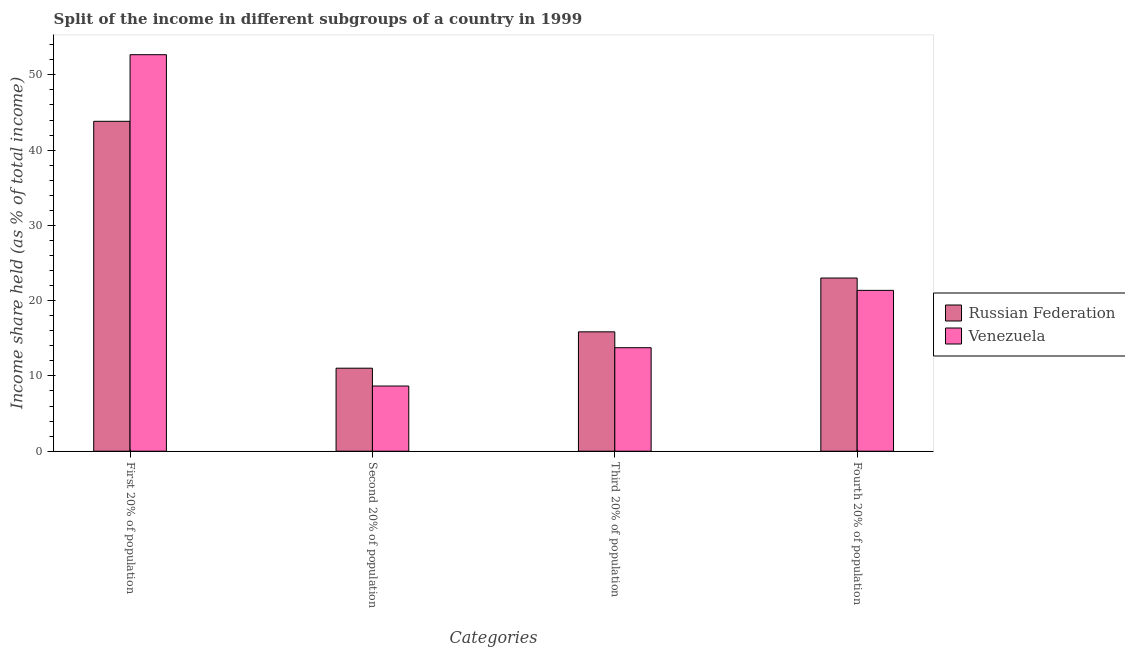How many different coloured bars are there?
Your response must be concise. 2. How many groups of bars are there?
Provide a succinct answer. 4. How many bars are there on the 1st tick from the left?
Your response must be concise. 2. How many bars are there on the 1st tick from the right?
Make the answer very short. 2. What is the label of the 4th group of bars from the left?
Provide a succinct answer. Fourth 20% of population. What is the share of the income held by third 20% of the population in Russian Federation?
Keep it short and to the point. 15.86. Across all countries, what is the maximum share of the income held by fourth 20% of the population?
Give a very brief answer. 23.01. Across all countries, what is the minimum share of the income held by third 20% of the population?
Offer a very short reply. 13.75. In which country was the share of the income held by first 20% of the population maximum?
Give a very brief answer. Venezuela. In which country was the share of the income held by second 20% of the population minimum?
Offer a terse response. Venezuela. What is the total share of the income held by third 20% of the population in the graph?
Offer a very short reply. 29.61. What is the difference between the share of the income held by second 20% of the population in Venezuela and that in Russian Federation?
Offer a terse response. -2.37. What is the difference between the share of the income held by second 20% of the population in Venezuela and the share of the income held by third 20% of the population in Russian Federation?
Your answer should be compact. -7.2. What is the average share of the income held by second 20% of the population per country?
Offer a very short reply. 9.84. What is the difference between the share of the income held by second 20% of the population and share of the income held by fourth 20% of the population in Russian Federation?
Your answer should be compact. -11.98. In how many countries, is the share of the income held by first 20% of the population greater than 34 %?
Give a very brief answer. 2. What is the ratio of the share of the income held by third 20% of the population in Venezuela to that in Russian Federation?
Offer a terse response. 0.87. Is the share of the income held by fourth 20% of the population in Russian Federation less than that in Venezuela?
Your response must be concise. No. Is the difference between the share of the income held by second 20% of the population in Russian Federation and Venezuela greater than the difference between the share of the income held by third 20% of the population in Russian Federation and Venezuela?
Make the answer very short. Yes. What is the difference between the highest and the second highest share of the income held by fourth 20% of the population?
Make the answer very short. 1.64. What is the difference between the highest and the lowest share of the income held by fourth 20% of the population?
Provide a short and direct response. 1.64. Is the sum of the share of the income held by first 20% of the population in Russian Federation and Venezuela greater than the maximum share of the income held by fourth 20% of the population across all countries?
Offer a very short reply. Yes. Is it the case that in every country, the sum of the share of the income held by fourth 20% of the population and share of the income held by first 20% of the population is greater than the sum of share of the income held by second 20% of the population and share of the income held by third 20% of the population?
Provide a succinct answer. Yes. What does the 2nd bar from the left in First 20% of population represents?
Provide a succinct answer. Venezuela. What does the 1st bar from the right in Fourth 20% of population represents?
Your answer should be very brief. Venezuela. What is the difference between two consecutive major ticks on the Y-axis?
Offer a terse response. 10. Are the values on the major ticks of Y-axis written in scientific E-notation?
Your answer should be very brief. No. Does the graph contain grids?
Offer a terse response. No. Where does the legend appear in the graph?
Make the answer very short. Center right. How many legend labels are there?
Provide a succinct answer. 2. What is the title of the graph?
Provide a short and direct response. Split of the income in different subgroups of a country in 1999. Does "Guinea" appear as one of the legend labels in the graph?
Your answer should be compact. No. What is the label or title of the X-axis?
Offer a terse response. Categories. What is the label or title of the Y-axis?
Ensure brevity in your answer.  Income share held (as % of total income). What is the Income share held (as % of total income) in Russian Federation in First 20% of population?
Your answer should be compact. 43.83. What is the Income share held (as % of total income) in Venezuela in First 20% of population?
Offer a terse response. 52.68. What is the Income share held (as % of total income) of Russian Federation in Second 20% of population?
Provide a short and direct response. 11.03. What is the Income share held (as % of total income) of Venezuela in Second 20% of population?
Provide a short and direct response. 8.66. What is the Income share held (as % of total income) in Russian Federation in Third 20% of population?
Your response must be concise. 15.86. What is the Income share held (as % of total income) in Venezuela in Third 20% of population?
Your answer should be very brief. 13.75. What is the Income share held (as % of total income) in Russian Federation in Fourth 20% of population?
Your answer should be compact. 23.01. What is the Income share held (as % of total income) of Venezuela in Fourth 20% of population?
Offer a terse response. 21.37. Across all Categories, what is the maximum Income share held (as % of total income) of Russian Federation?
Give a very brief answer. 43.83. Across all Categories, what is the maximum Income share held (as % of total income) of Venezuela?
Make the answer very short. 52.68. Across all Categories, what is the minimum Income share held (as % of total income) of Russian Federation?
Make the answer very short. 11.03. Across all Categories, what is the minimum Income share held (as % of total income) in Venezuela?
Offer a very short reply. 8.66. What is the total Income share held (as % of total income) of Russian Federation in the graph?
Offer a terse response. 93.73. What is the total Income share held (as % of total income) in Venezuela in the graph?
Make the answer very short. 96.46. What is the difference between the Income share held (as % of total income) in Russian Federation in First 20% of population and that in Second 20% of population?
Make the answer very short. 32.8. What is the difference between the Income share held (as % of total income) of Venezuela in First 20% of population and that in Second 20% of population?
Your answer should be very brief. 44.02. What is the difference between the Income share held (as % of total income) of Russian Federation in First 20% of population and that in Third 20% of population?
Your answer should be very brief. 27.97. What is the difference between the Income share held (as % of total income) in Venezuela in First 20% of population and that in Third 20% of population?
Keep it short and to the point. 38.93. What is the difference between the Income share held (as % of total income) in Russian Federation in First 20% of population and that in Fourth 20% of population?
Offer a terse response. 20.82. What is the difference between the Income share held (as % of total income) in Venezuela in First 20% of population and that in Fourth 20% of population?
Keep it short and to the point. 31.31. What is the difference between the Income share held (as % of total income) in Russian Federation in Second 20% of population and that in Third 20% of population?
Provide a short and direct response. -4.83. What is the difference between the Income share held (as % of total income) in Venezuela in Second 20% of population and that in Third 20% of population?
Your answer should be very brief. -5.09. What is the difference between the Income share held (as % of total income) in Russian Federation in Second 20% of population and that in Fourth 20% of population?
Keep it short and to the point. -11.98. What is the difference between the Income share held (as % of total income) of Venezuela in Second 20% of population and that in Fourth 20% of population?
Give a very brief answer. -12.71. What is the difference between the Income share held (as % of total income) of Russian Federation in Third 20% of population and that in Fourth 20% of population?
Provide a short and direct response. -7.15. What is the difference between the Income share held (as % of total income) in Venezuela in Third 20% of population and that in Fourth 20% of population?
Make the answer very short. -7.62. What is the difference between the Income share held (as % of total income) of Russian Federation in First 20% of population and the Income share held (as % of total income) of Venezuela in Second 20% of population?
Your answer should be very brief. 35.17. What is the difference between the Income share held (as % of total income) of Russian Federation in First 20% of population and the Income share held (as % of total income) of Venezuela in Third 20% of population?
Your answer should be very brief. 30.08. What is the difference between the Income share held (as % of total income) of Russian Federation in First 20% of population and the Income share held (as % of total income) of Venezuela in Fourth 20% of population?
Ensure brevity in your answer.  22.46. What is the difference between the Income share held (as % of total income) in Russian Federation in Second 20% of population and the Income share held (as % of total income) in Venezuela in Third 20% of population?
Offer a terse response. -2.72. What is the difference between the Income share held (as % of total income) in Russian Federation in Second 20% of population and the Income share held (as % of total income) in Venezuela in Fourth 20% of population?
Offer a very short reply. -10.34. What is the difference between the Income share held (as % of total income) of Russian Federation in Third 20% of population and the Income share held (as % of total income) of Venezuela in Fourth 20% of population?
Your response must be concise. -5.51. What is the average Income share held (as % of total income) of Russian Federation per Categories?
Your answer should be compact. 23.43. What is the average Income share held (as % of total income) of Venezuela per Categories?
Offer a terse response. 24.11. What is the difference between the Income share held (as % of total income) in Russian Federation and Income share held (as % of total income) in Venezuela in First 20% of population?
Make the answer very short. -8.85. What is the difference between the Income share held (as % of total income) of Russian Federation and Income share held (as % of total income) of Venezuela in Second 20% of population?
Give a very brief answer. 2.37. What is the difference between the Income share held (as % of total income) in Russian Federation and Income share held (as % of total income) in Venezuela in Third 20% of population?
Make the answer very short. 2.11. What is the difference between the Income share held (as % of total income) in Russian Federation and Income share held (as % of total income) in Venezuela in Fourth 20% of population?
Give a very brief answer. 1.64. What is the ratio of the Income share held (as % of total income) in Russian Federation in First 20% of population to that in Second 20% of population?
Make the answer very short. 3.97. What is the ratio of the Income share held (as % of total income) of Venezuela in First 20% of population to that in Second 20% of population?
Keep it short and to the point. 6.08. What is the ratio of the Income share held (as % of total income) in Russian Federation in First 20% of population to that in Third 20% of population?
Your answer should be very brief. 2.76. What is the ratio of the Income share held (as % of total income) of Venezuela in First 20% of population to that in Third 20% of population?
Give a very brief answer. 3.83. What is the ratio of the Income share held (as % of total income) in Russian Federation in First 20% of population to that in Fourth 20% of population?
Keep it short and to the point. 1.9. What is the ratio of the Income share held (as % of total income) in Venezuela in First 20% of population to that in Fourth 20% of population?
Offer a terse response. 2.47. What is the ratio of the Income share held (as % of total income) of Russian Federation in Second 20% of population to that in Third 20% of population?
Your answer should be compact. 0.7. What is the ratio of the Income share held (as % of total income) of Venezuela in Second 20% of population to that in Third 20% of population?
Provide a succinct answer. 0.63. What is the ratio of the Income share held (as % of total income) in Russian Federation in Second 20% of population to that in Fourth 20% of population?
Offer a very short reply. 0.48. What is the ratio of the Income share held (as % of total income) of Venezuela in Second 20% of population to that in Fourth 20% of population?
Your response must be concise. 0.41. What is the ratio of the Income share held (as % of total income) of Russian Federation in Third 20% of population to that in Fourth 20% of population?
Provide a short and direct response. 0.69. What is the ratio of the Income share held (as % of total income) of Venezuela in Third 20% of population to that in Fourth 20% of population?
Your answer should be compact. 0.64. What is the difference between the highest and the second highest Income share held (as % of total income) in Russian Federation?
Your response must be concise. 20.82. What is the difference between the highest and the second highest Income share held (as % of total income) in Venezuela?
Your response must be concise. 31.31. What is the difference between the highest and the lowest Income share held (as % of total income) in Russian Federation?
Make the answer very short. 32.8. What is the difference between the highest and the lowest Income share held (as % of total income) of Venezuela?
Offer a very short reply. 44.02. 